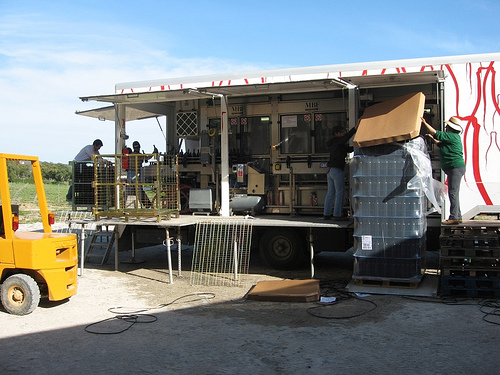<image>
Is there a glass under the steel? No. The glass is not positioned under the steel. The vertical relationship between these objects is different. 